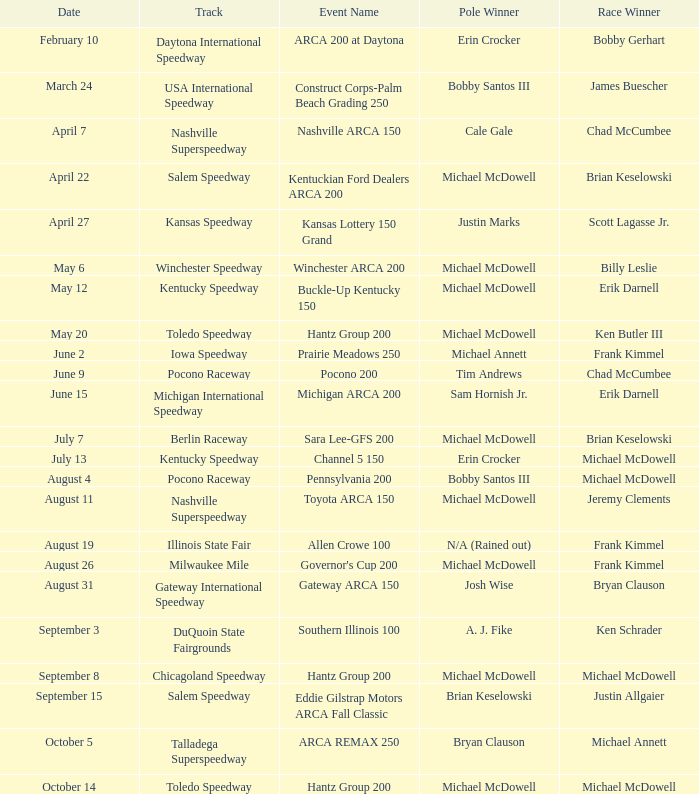Help me parse the entirety of this table. {'header': ['Date', 'Track', 'Event Name', 'Pole Winner', 'Race Winner'], 'rows': [['February 10', 'Daytona International Speedway', 'ARCA 200 at Daytona', 'Erin Crocker', 'Bobby Gerhart'], ['March 24', 'USA International Speedway', 'Construct Corps-Palm Beach Grading 250', 'Bobby Santos III', 'James Buescher'], ['April 7', 'Nashville Superspeedway', 'Nashville ARCA 150', 'Cale Gale', 'Chad McCumbee'], ['April 22', 'Salem Speedway', 'Kentuckian Ford Dealers ARCA 200', 'Michael McDowell', 'Brian Keselowski'], ['April 27', 'Kansas Speedway', 'Kansas Lottery 150 Grand', 'Justin Marks', 'Scott Lagasse Jr.'], ['May 6', 'Winchester Speedway', 'Winchester ARCA 200', 'Michael McDowell', 'Billy Leslie'], ['May 12', 'Kentucky Speedway', 'Buckle-Up Kentucky 150', 'Michael McDowell', 'Erik Darnell'], ['May 20', 'Toledo Speedway', 'Hantz Group 200', 'Michael McDowell', 'Ken Butler III'], ['June 2', 'Iowa Speedway', 'Prairie Meadows 250', 'Michael Annett', 'Frank Kimmel'], ['June 9', 'Pocono Raceway', 'Pocono 200', 'Tim Andrews', 'Chad McCumbee'], ['June 15', 'Michigan International Speedway', 'Michigan ARCA 200', 'Sam Hornish Jr.', 'Erik Darnell'], ['July 7', 'Berlin Raceway', 'Sara Lee-GFS 200', 'Michael McDowell', 'Brian Keselowski'], ['July 13', 'Kentucky Speedway', 'Channel 5 150', 'Erin Crocker', 'Michael McDowell'], ['August 4', 'Pocono Raceway', 'Pennsylvania 200', 'Bobby Santos III', 'Michael McDowell'], ['August 11', 'Nashville Superspeedway', 'Toyota ARCA 150', 'Michael McDowell', 'Jeremy Clements'], ['August 19', 'Illinois State Fair', 'Allen Crowe 100', 'N/A (Rained out)', 'Frank Kimmel'], ['August 26', 'Milwaukee Mile', "Governor's Cup 200", 'Michael McDowell', 'Frank Kimmel'], ['August 31', 'Gateway International Speedway', 'Gateway ARCA 150', 'Josh Wise', 'Bryan Clauson'], ['September 3', 'DuQuoin State Fairgrounds', 'Southern Illinois 100', 'A. J. Fike', 'Ken Schrader'], ['September 8', 'Chicagoland Speedway', 'Hantz Group 200', 'Michael McDowell', 'Michael McDowell'], ['September 15', 'Salem Speedway', 'Eddie Gilstrap Motors ARCA Fall Classic', 'Brian Keselowski', 'Justin Allgaier'], ['October 5', 'Talladega Superspeedway', 'ARCA REMAX 250', 'Bryan Clauson', 'Michael Annett'], ['October 14', 'Toledo Speedway', 'Hantz Group 200', 'Michael McDowell', 'Michael McDowell']]} Tell me the pole winner of may 12 Michael McDowell. 